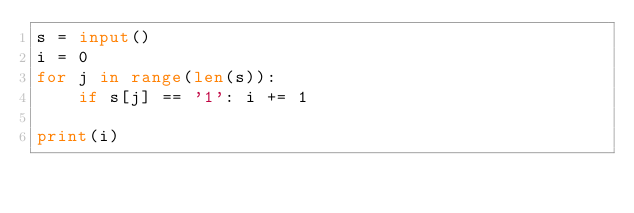Convert code to text. <code><loc_0><loc_0><loc_500><loc_500><_Python_>s = input()
i = 0
for j in range(len(s)):
    if s[j] == '1': i += 1

print(i)</code> 